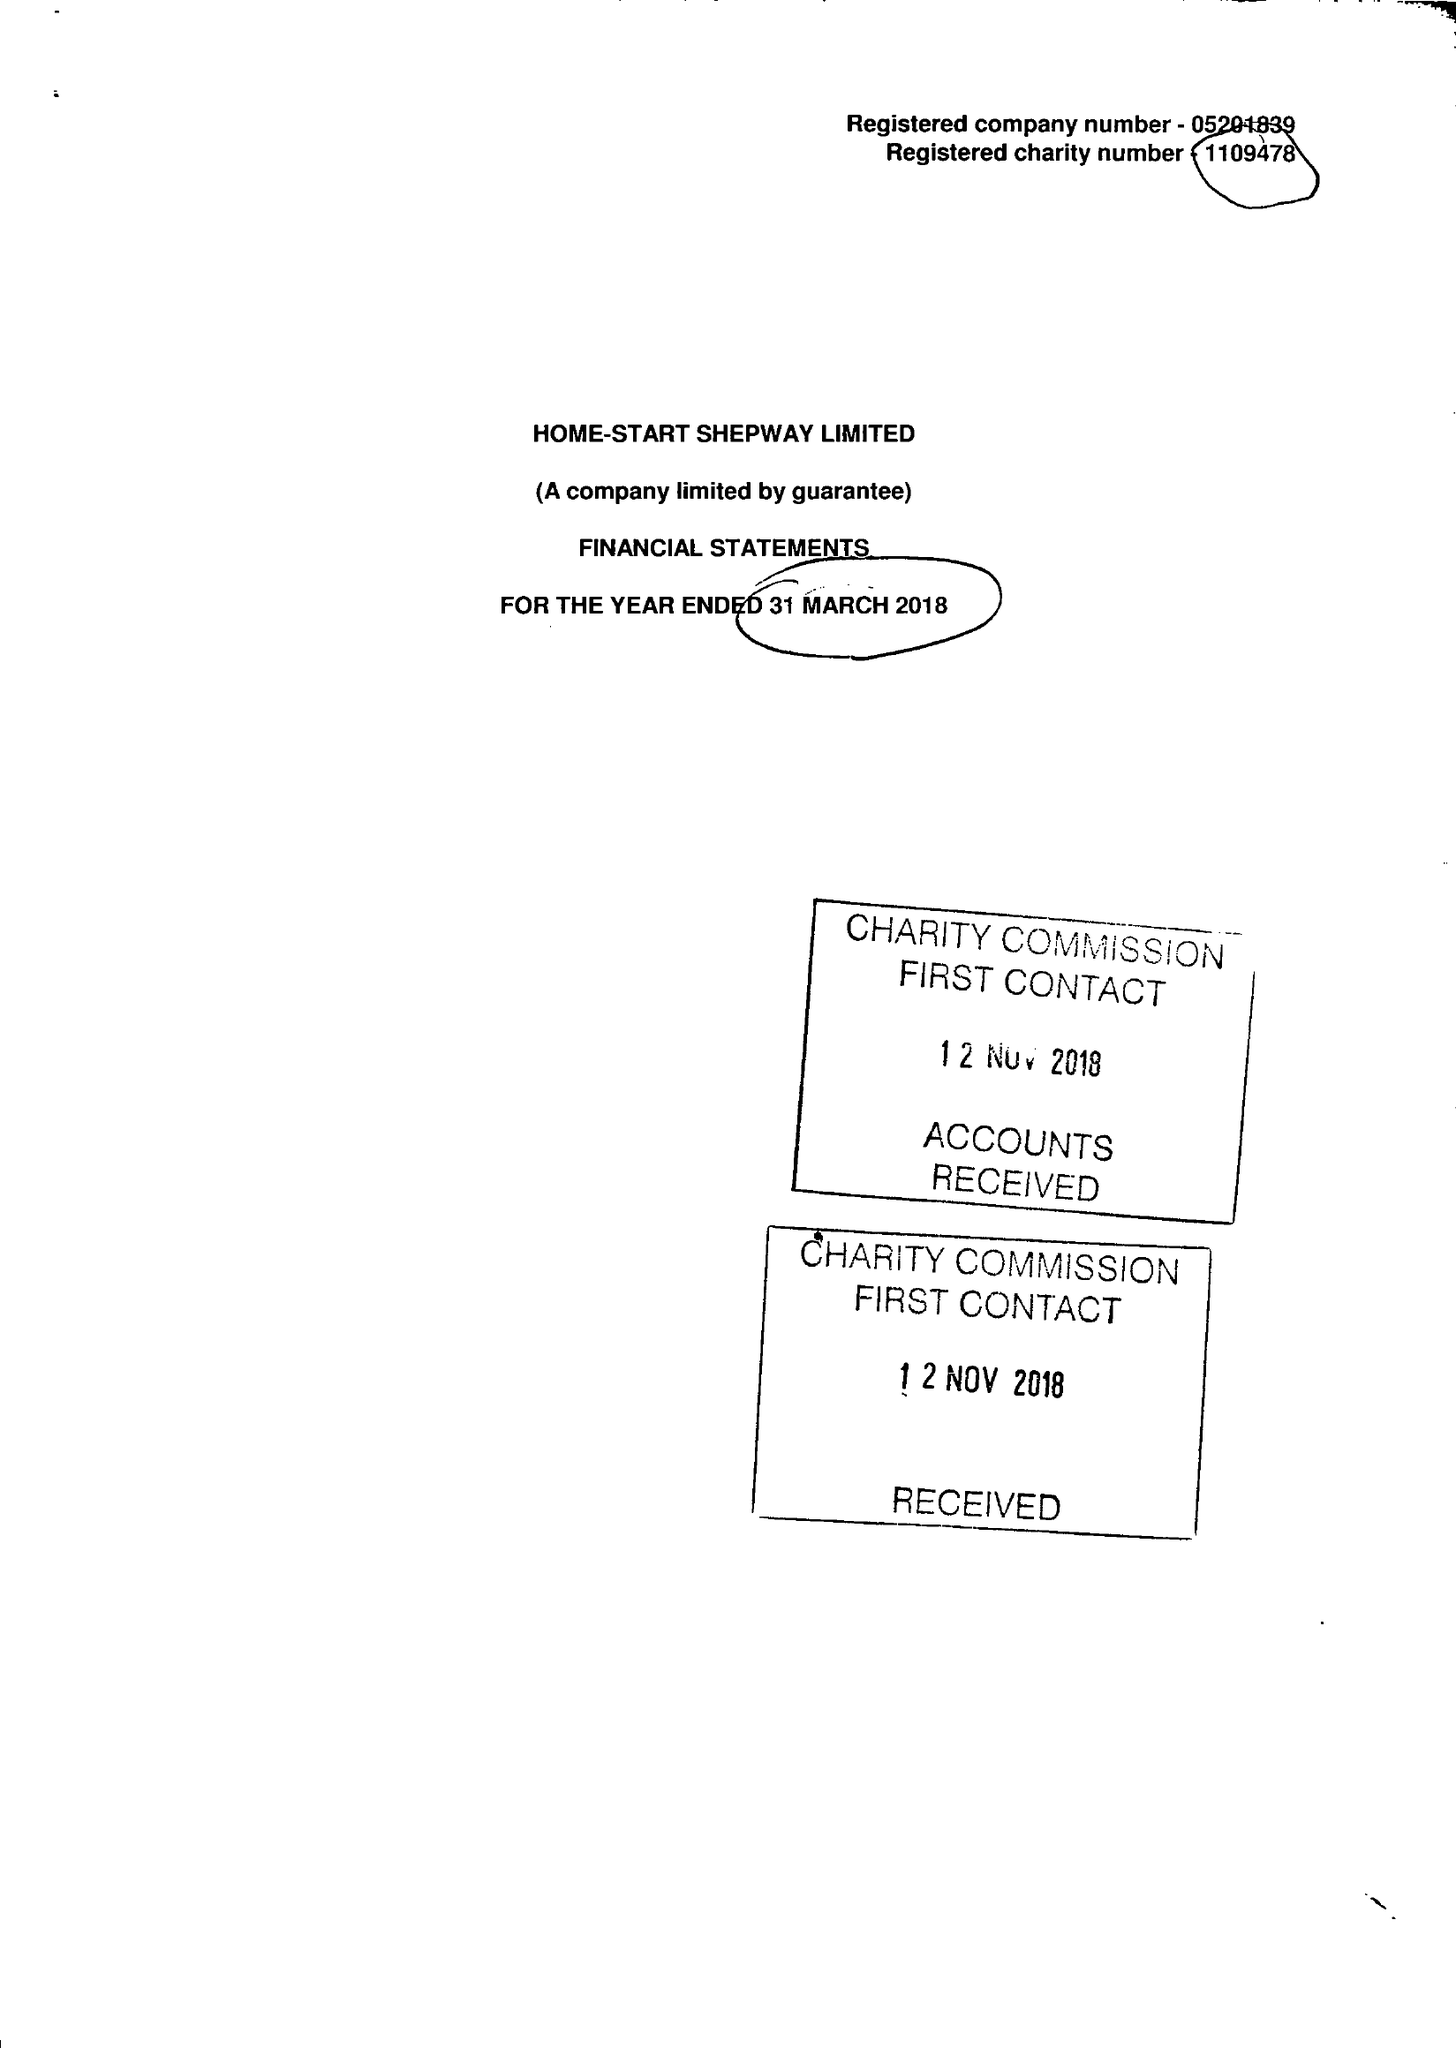What is the value for the address__post_town?
Answer the question using a single word or phrase. FOLKESTONE 